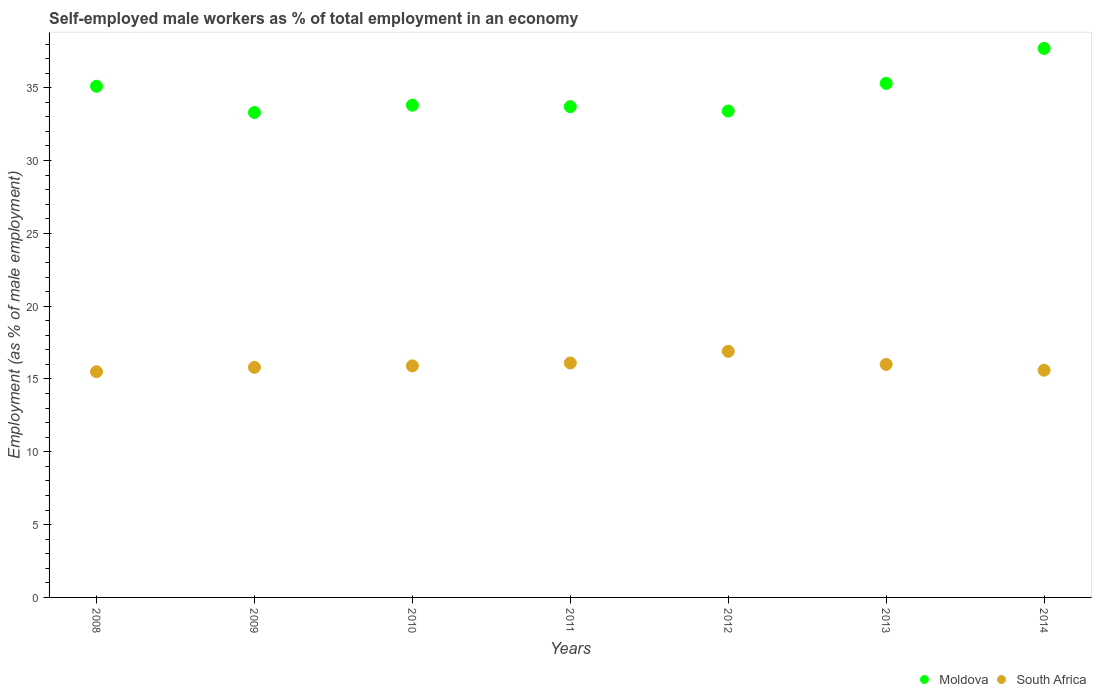Is the number of dotlines equal to the number of legend labels?
Your response must be concise. Yes. What is the percentage of self-employed male workers in South Africa in 2010?
Your answer should be compact. 15.9. Across all years, what is the maximum percentage of self-employed male workers in Moldova?
Give a very brief answer. 37.7. Across all years, what is the minimum percentage of self-employed male workers in Moldova?
Ensure brevity in your answer.  33.3. What is the total percentage of self-employed male workers in South Africa in the graph?
Keep it short and to the point. 111.8. What is the difference between the percentage of self-employed male workers in South Africa in 2011 and that in 2013?
Your response must be concise. 0.1. What is the difference between the percentage of self-employed male workers in South Africa in 2011 and the percentage of self-employed male workers in Moldova in 2010?
Give a very brief answer. -17.7. What is the average percentage of self-employed male workers in Moldova per year?
Offer a terse response. 34.61. In the year 2008, what is the difference between the percentage of self-employed male workers in Moldova and percentage of self-employed male workers in South Africa?
Provide a succinct answer. 19.6. In how many years, is the percentage of self-employed male workers in South Africa greater than 19 %?
Give a very brief answer. 0. What is the ratio of the percentage of self-employed male workers in Moldova in 2009 to that in 2011?
Keep it short and to the point. 0.99. Is the difference between the percentage of self-employed male workers in Moldova in 2009 and 2010 greater than the difference between the percentage of self-employed male workers in South Africa in 2009 and 2010?
Ensure brevity in your answer.  No. What is the difference between the highest and the second highest percentage of self-employed male workers in South Africa?
Your answer should be compact. 0.8. What is the difference between the highest and the lowest percentage of self-employed male workers in South Africa?
Make the answer very short. 1.4. In how many years, is the percentage of self-employed male workers in Moldova greater than the average percentage of self-employed male workers in Moldova taken over all years?
Provide a short and direct response. 3. Is the percentage of self-employed male workers in Moldova strictly greater than the percentage of self-employed male workers in South Africa over the years?
Your answer should be very brief. Yes. How many dotlines are there?
Offer a very short reply. 2. How many years are there in the graph?
Make the answer very short. 7. What is the difference between two consecutive major ticks on the Y-axis?
Keep it short and to the point. 5. Does the graph contain any zero values?
Provide a short and direct response. No. What is the title of the graph?
Provide a succinct answer. Self-employed male workers as % of total employment in an economy. What is the label or title of the Y-axis?
Offer a very short reply. Employment (as % of male employment). What is the Employment (as % of male employment) in Moldova in 2008?
Your response must be concise. 35.1. What is the Employment (as % of male employment) of South Africa in 2008?
Your answer should be very brief. 15.5. What is the Employment (as % of male employment) in Moldova in 2009?
Keep it short and to the point. 33.3. What is the Employment (as % of male employment) in South Africa in 2009?
Your answer should be compact. 15.8. What is the Employment (as % of male employment) of Moldova in 2010?
Offer a terse response. 33.8. What is the Employment (as % of male employment) of South Africa in 2010?
Your answer should be compact. 15.9. What is the Employment (as % of male employment) in Moldova in 2011?
Offer a very short reply. 33.7. What is the Employment (as % of male employment) of South Africa in 2011?
Your answer should be compact. 16.1. What is the Employment (as % of male employment) in Moldova in 2012?
Give a very brief answer. 33.4. What is the Employment (as % of male employment) in South Africa in 2012?
Offer a terse response. 16.9. What is the Employment (as % of male employment) of Moldova in 2013?
Provide a succinct answer. 35.3. What is the Employment (as % of male employment) in South Africa in 2013?
Provide a succinct answer. 16. What is the Employment (as % of male employment) in Moldova in 2014?
Your response must be concise. 37.7. What is the Employment (as % of male employment) of South Africa in 2014?
Keep it short and to the point. 15.6. Across all years, what is the maximum Employment (as % of male employment) in Moldova?
Keep it short and to the point. 37.7. Across all years, what is the maximum Employment (as % of male employment) in South Africa?
Offer a terse response. 16.9. Across all years, what is the minimum Employment (as % of male employment) in Moldova?
Your answer should be compact. 33.3. Across all years, what is the minimum Employment (as % of male employment) of South Africa?
Provide a succinct answer. 15.5. What is the total Employment (as % of male employment) in Moldova in the graph?
Keep it short and to the point. 242.3. What is the total Employment (as % of male employment) of South Africa in the graph?
Offer a very short reply. 111.8. What is the difference between the Employment (as % of male employment) in Moldova in 2008 and that in 2011?
Keep it short and to the point. 1.4. What is the difference between the Employment (as % of male employment) of South Africa in 2008 and that in 2011?
Your answer should be compact. -0.6. What is the difference between the Employment (as % of male employment) of Moldova in 2008 and that in 2012?
Ensure brevity in your answer.  1.7. What is the difference between the Employment (as % of male employment) of South Africa in 2008 and that in 2012?
Provide a succinct answer. -1.4. What is the difference between the Employment (as % of male employment) in Moldova in 2008 and that in 2013?
Make the answer very short. -0.2. What is the difference between the Employment (as % of male employment) in South Africa in 2008 and that in 2014?
Provide a succinct answer. -0.1. What is the difference between the Employment (as % of male employment) in South Africa in 2009 and that in 2010?
Ensure brevity in your answer.  -0.1. What is the difference between the Employment (as % of male employment) of Moldova in 2009 and that in 2012?
Provide a succinct answer. -0.1. What is the difference between the Employment (as % of male employment) in South Africa in 2009 and that in 2012?
Keep it short and to the point. -1.1. What is the difference between the Employment (as % of male employment) of Moldova in 2009 and that in 2013?
Your response must be concise. -2. What is the difference between the Employment (as % of male employment) of Moldova in 2009 and that in 2014?
Give a very brief answer. -4.4. What is the difference between the Employment (as % of male employment) of South Africa in 2009 and that in 2014?
Your answer should be compact. 0.2. What is the difference between the Employment (as % of male employment) of Moldova in 2010 and that in 2011?
Ensure brevity in your answer.  0.1. What is the difference between the Employment (as % of male employment) in South Africa in 2010 and that in 2011?
Your response must be concise. -0.2. What is the difference between the Employment (as % of male employment) of Moldova in 2010 and that in 2012?
Provide a succinct answer. 0.4. What is the difference between the Employment (as % of male employment) in South Africa in 2010 and that in 2013?
Provide a succinct answer. -0.1. What is the difference between the Employment (as % of male employment) of South Africa in 2010 and that in 2014?
Your response must be concise. 0.3. What is the difference between the Employment (as % of male employment) of Moldova in 2011 and that in 2012?
Your response must be concise. 0.3. What is the difference between the Employment (as % of male employment) of South Africa in 2011 and that in 2012?
Offer a terse response. -0.8. What is the difference between the Employment (as % of male employment) in South Africa in 2011 and that in 2014?
Offer a very short reply. 0.5. What is the difference between the Employment (as % of male employment) of South Africa in 2012 and that in 2013?
Make the answer very short. 0.9. What is the difference between the Employment (as % of male employment) in Moldova in 2013 and that in 2014?
Ensure brevity in your answer.  -2.4. What is the difference between the Employment (as % of male employment) of Moldova in 2008 and the Employment (as % of male employment) of South Africa in 2009?
Provide a short and direct response. 19.3. What is the difference between the Employment (as % of male employment) of Moldova in 2008 and the Employment (as % of male employment) of South Africa in 2011?
Ensure brevity in your answer.  19. What is the difference between the Employment (as % of male employment) of Moldova in 2008 and the Employment (as % of male employment) of South Africa in 2012?
Give a very brief answer. 18.2. What is the difference between the Employment (as % of male employment) of Moldova in 2008 and the Employment (as % of male employment) of South Africa in 2014?
Ensure brevity in your answer.  19.5. What is the difference between the Employment (as % of male employment) of Moldova in 2009 and the Employment (as % of male employment) of South Africa in 2011?
Ensure brevity in your answer.  17.2. What is the difference between the Employment (as % of male employment) of Moldova in 2009 and the Employment (as % of male employment) of South Africa in 2012?
Provide a succinct answer. 16.4. What is the difference between the Employment (as % of male employment) of Moldova in 2009 and the Employment (as % of male employment) of South Africa in 2013?
Your response must be concise. 17.3. What is the difference between the Employment (as % of male employment) of Moldova in 2009 and the Employment (as % of male employment) of South Africa in 2014?
Provide a short and direct response. 17.7. What is the difference between the Employment (as % of male employment) in Moldova in 2010 and the Employment (as % of male employment) in South Africa in 2012?
Your answer should be very brief. 16.9. What is the difference between the Employment (as % of male employment) in Moldova in 2010 and the Employment (as % of male employment) in South Africa in 2013?
Your answer should be very brief. 17.8. What is the difference between the Employment (as % of male employment) in Moldova in 2010 and the Employment (as % of male employment) in South Africa in 2014?
Offer a terse response. 18.2. What is the difference between the Employment (as % of male employment) in Moldova in 2011 and the Employment (as % of male employment) in South Africa in 2013?
Give a very brief answer. 17.7. What is the difference between the Employment (as % of male employment) in Moldova in 2011 and the Employment (as % of male employment) in South Africa in 2014?
Offer a very short reply. 18.1. What is the difference between the Employment (as % of male employment) in Moldova in 2012 and the Employment (as % of male employment) in South Africa in 2013?
Your answer should be very brief. 17.4. What is the difference between the Employment (as % of male employment) in Moldova in 2012 and the Employment (as % of male employment) in South Africa in 2014?
Offer a very short reply. 17.8. What is the average Employment (as % of male employment) of Moldova per year?
Ensure brevity in your answer.  34.61. What is the average Employment (as % of male employment) in South Africa per year?
Keep it short and to the point. 15.97. In the year 2008, what is the difference between the Employment (as % of male employment) of Moldova and Employment (as % of male employment) of South Africa?
Your response must be concise. 19.6. In the year 2009, what is the difference between the Employment (as % of male employment) of Moldova and Employment (as % of male employment) of South Africa?
Make the answer very short. 17.5. In the year 2011, what is the difference between the Employment (as % of male employment) of Moldova and Employment (as % of male employment) of South Africa?
Make the answer very short. 17.6. In the year 2012, what is the difference between the Employment (as % of male employment) in Moldova and Employment (as % of male employment) in South Africa?
Keep it short and to the point. 16.5. In the year 2013, what is the difference between the Employment (as % of male employment) in Moldova and Employment (as % of male employment) in South Africa?
Make the answer very short. 19.3. In the year 2014, what is the difference between the Employment (as % of male employment) in Moldova and Employment (as % of male employment) in South Africa?
Offer a terse response. 22.1. What is the ratio of the Employment (as % of male employment) of Moldova in 2008 to that in 2009?
Your answer should be compact. 1.05. What is the ratio of the Employment (as % of male employment) in South Africa in 2008 to that in 2009?
Provide a short and direct response. 0.98. What is the ratio of the Employment (as % of male employment) of Moldova in 2008 to that in 2010?
Ensure brevity in your answer.  1.04. What is the ratio of the Employment (as % of male employment) in South Africa in 2008 to that in 2010?
Your answer should be very brief. 0.97. What is the ratio of the Employment (as % of male employment) in Moldova in 2008 to that in 2011?
Your answer should be compact. 1.04. What is the ratio of the Employment (as % of male employment) in South Africa in 2008 to that in 2011?
Offer a terse response. 0.96. What is the ratio of the Employment (as % of male employment) in Moldova in 2008 to that in 2012?
Ensure brevity in your answer.  1.05. What is the ratio of the Employment (as % of male employment) of South Africa in 2008 to that in 2012?
Offer a very short reply. 0.92. What is the ratio of the Employment (as % of male employment) in South Africa in 2008 to that in 2013?
Your response must be concise. 0.97. What is the ratio of the Employment (as % of male employment) in South Africa in 2008 to that in 2014?
Offer a very short reply. 0.99. What is the ratio of the Employment (as % of male employment) of Moldova in 2009 to that in 2010?
Your answer should be very brief. 0.99. What is the ratio of the Employment (as % of male employment) of South Africa in 2009 to that in 2010?
Offer a terse response. 0.99. What is the ratio of the Employment (as % of male employment) of Moldova in 2009 to that in 2011?
Offer a very short reply. 0.99. What is the ratio of the Employment (as % of male employment) of South Africa in 2009 to that in 2011?
Your answer should be compact. 0.98. What is the ratio of the Employment (as % of male employment) of South Africa in 2009 to that in 2012?
Keep it short and to the point. 0.93. What is the ratio of the Employment (as % of male employment) of Moldova in 2009 to that in 2013?
Your response must be concise. 0.94. What is the ratio of the Employment (as % of male employment) of South Africa in 2009 to that in 2013?
Give a very brief answer. 0.99. What is the ratio of the Employment (as % of male employment) in Moldova in 2009 to that in 2014?
Provide a short and direct response. 0.88. What is the ratio of the Employment (as % of male employment) in South Africa in 2009 to that in 2014?
Make the answer very short. 1.01. What is the ratio of the Employment (as % of male employment) of Moldova in 2010 to that in 2011?
Provide a succinct answer. 1. What is the ratio of the Employment (as % of male employment) of South Africa in 2010 to that in 2011?
Provide a short and direct response. 0.99. What is the ratio of the Employment (as % of male employment) in Moldova in 2010 to that in 2012?
Provide a short and direct response. 1.01. What is the ratio of the Employment (as % of male employment) in South Africa in 2010 to that in 2012?
Offer a very short reply. 0.94. What is the ratio of the Employment (as % of male employment) in Moldova in 2010 to that in 2013?
Offer a terse response. 0.96. What is the ratio of the Employment (as % of male employment) in Moldova in 2010 to that in 2014?
Your answer should be compact. 0.9. What is the ratio of the Employment (as % of male employment) in South Africa in 2010 to that in 2014?
Keep it short and to the point. 1.02. What is the ratio of the Employment (as % of male employment) in Moldova in 2011 to that in 2012?
Ensure brevity in your answer.  1.01. What is the ratio of the Employment (as % of male employment) of South Africa in 2011 to that in 2012?
Give a very brief answer. 0.95. What is the ratio of the Employment (as % of male employment) of Moldova in 2011 to that in 2013?
Your answer should be compact. 0.95. What is the ratio of the Employment (as % of male employment) in Moldova in 2011 to that in 2014?
Your answer should be very brief. 0.89. What is the ratio of the Employment (as % of male employment) of South Africa in 2011 to that in 2014?
Offer a very short reply. 1.03. What is the ratio of the Employment (as % of male employment) in Moldova in 2012 to that in 2013?
Offer a terse response. 0.95. What is the ratio of the Employment (as % of male employment) in South Africa in 2012 to that in 2013?
Your answer should be compact. 1.06. What is the ratio of the Employment (as % of male employment) in Moldova in 2012 to that in 2014?
Ensure brevity in your answer.  0.89. What is the ratio of the Employment (as % of male employment) of Moldova in 2013 to that in 2014?
Keep it short and to the point. 0.94. What is the ratio of the Employment (as % of male employment) of South Africa in 2013 to that in 2014?
Offer a terse response. 1.03. What is the difference between the highest and the second highest Employment (as % of male employment) in Moldova?
Offer a very short reply. 2.4. What is the difference between the highest and the second highest Employment (as % of male employment) in South Africa?
Offer a terse response. 0.8. What is the difference between the highest and the lowest Employment (as % of male employment) of Moldova?
Keep it short and to the point. 4.4. 